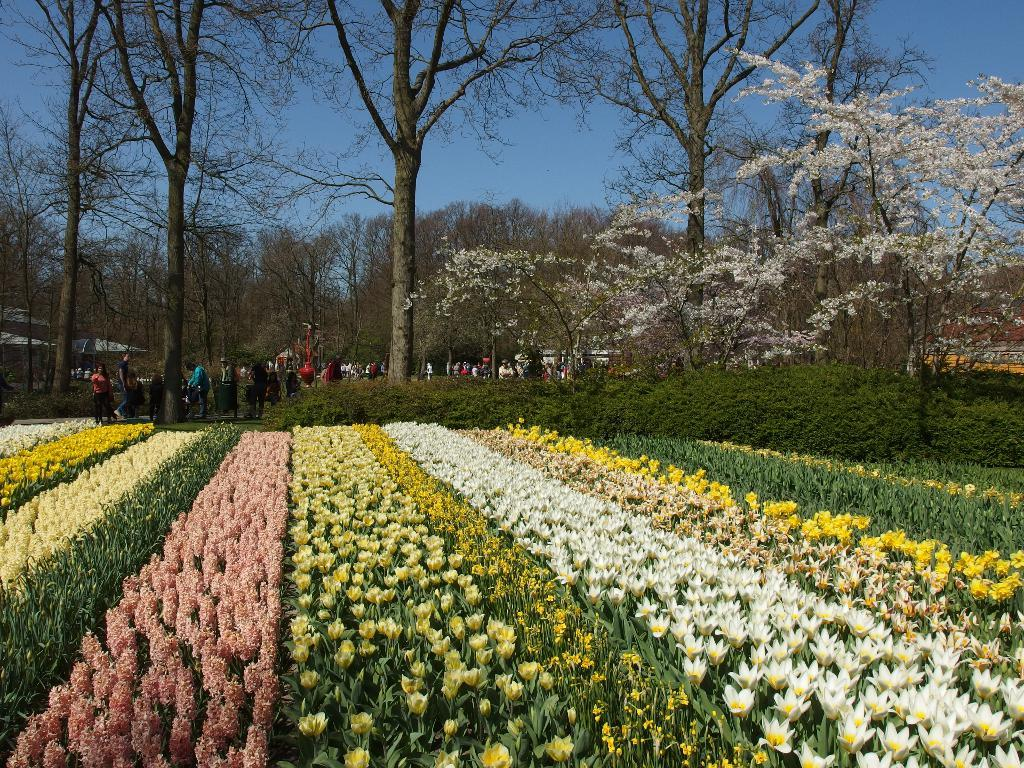What type of plants can be seen in the image? There is a group of plants with flowers in the image. Can you describe the people in the image? There are people standing in the image. What other natural elements are present in the image? There is a group of trees in the image. What type of temporary shelter is visible in the image? There are tents in the image. How would you describe the weather based on the sky in the image? The sky is visible in the image and appears cloudy. What type of potato is being rewarded for its hate in the image? There is no potato or mention of hate in the image; it features a group of plants with flowers, people, trees, tents, and a cloudy sky. 